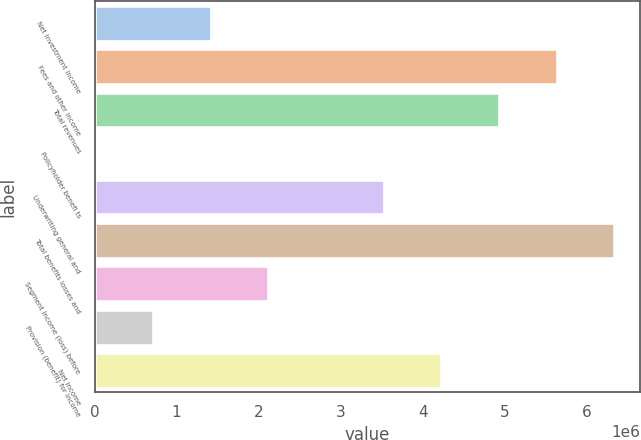Convert chart to OTSL. <chart><loc_0><loc_0><loc_500><loc_500><bar_chart><fcel>Net investment income<fcel>Fees and other income<fcel>Total revenues<fcel>Policyholder benefi ts<fcel>Underwriting general and<fcel>Total benefits losses and<fcel>Segment income (loss) before<fcel>Provision (benefit) for income<fcel>Net income<nl><fcel>1.41325e+06<fcel>5.63078e+06<fcel>4.92786e+06<fcel>7408<fcel>3.52202e+06<fcel>6.3337e+06<fcel>2.11617e+06<fcel>710330<fcel>4.22494e+06<nl></chart> 